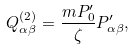Convert formula to latex. <formula><loc_0><loc_0><loc_500><loc_500>Q _ { \alpha \beta } ^ { ( 2 ) } = \frac { m P _ { 0 } ^ { \prime } } { \zeta } P _ { \alpha \beta } ^ { \prime } ,</formula> 